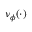Convert formula to latex. <formula><loc_0><loc_0><loc_500><loc_500>\nu _ { \phi } ( \cdot )</formula> 